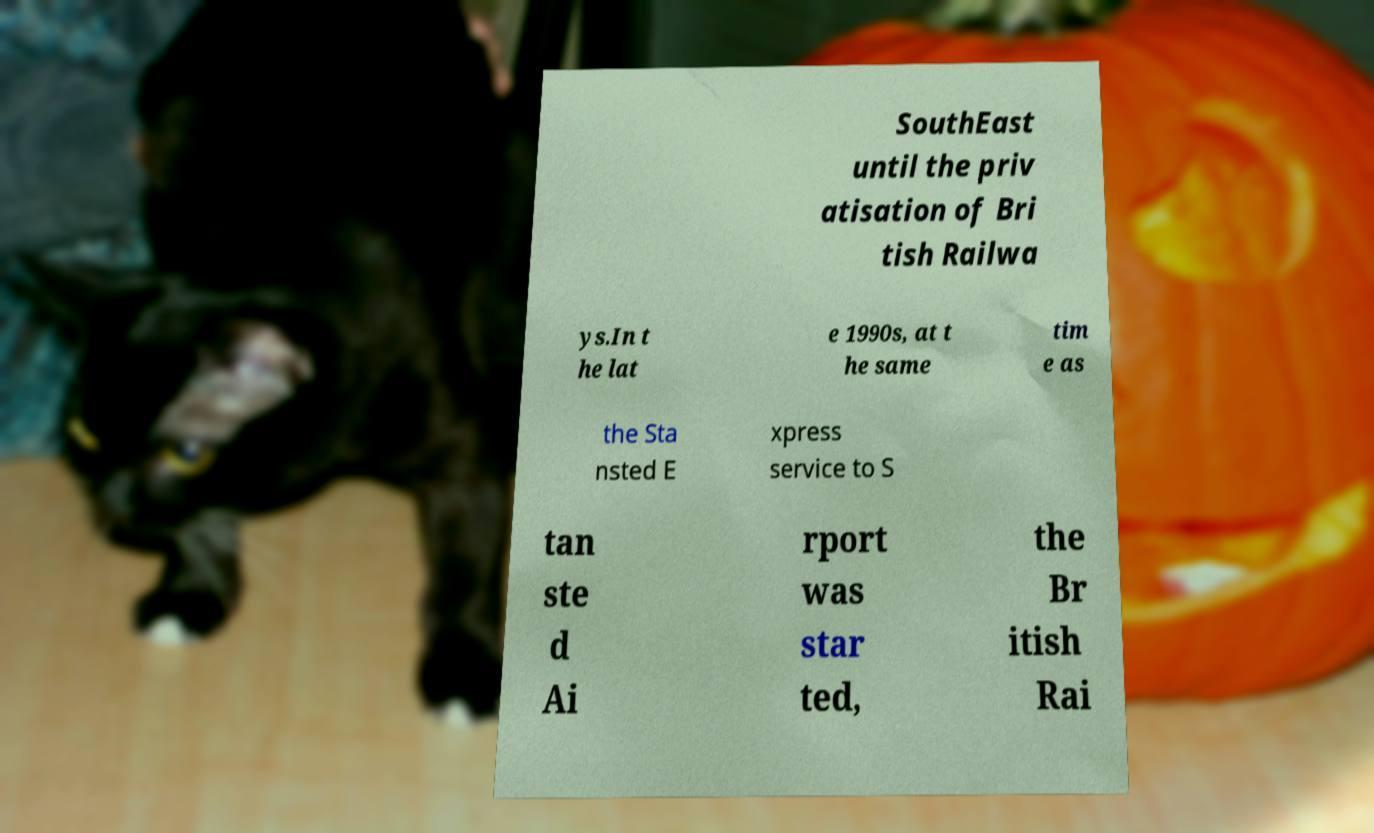Can you read and provide the text displayed in the image?This photo seems to have some interesting text. Can you extract and type it out for me? SouthEast until the priv atisation of Bri tish Railwa ys.In t he lat e 1990s, at t he same tim e as the Sta nsted E xpress service to S tan ste d Ai rport was star ted, the Br itish Rai 